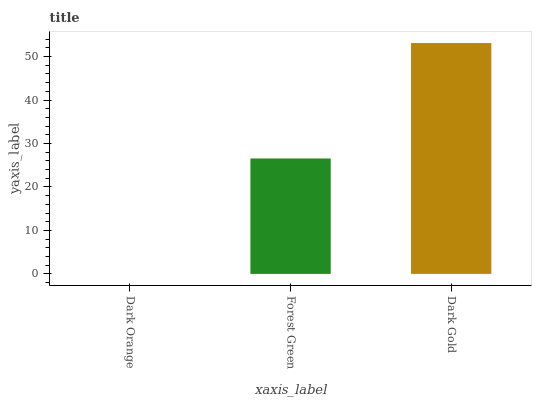Is Dark Orange the minimum?
Answer yes or no. Yes. Is Dark Gold the maximum?
Answer yes or no. Yes. Is Forest Green the minimum?
Answer yes or no. No. Is Forest Green the maximum?
Answer yes or no. No. Is Forest Green greater than Dark Orange?
Answer yes or no. Yes. Is Dark Orange less than Forest Green?
Answer yes or no. Yes. Is Dark Orange greater than Forest Green?
Answer yes or no. No. Is Forest Green less than Dark Orange?
Answer yes or no. No. Is Forest Green the high median?
Answer yes or no. Yes. Is Forest Green the low median?
Answer yes or no. Yes. Is Dark Gold the high median?
Answer yes or no. No. Is Dark Gold the low median?
Answer yes or no. No. 